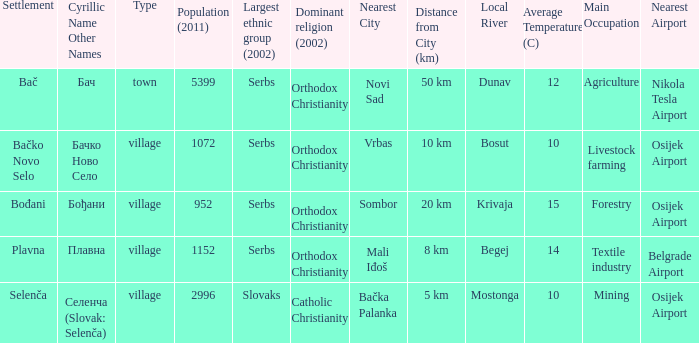How to you write  плавна with the latin alphabet? Plavna. 